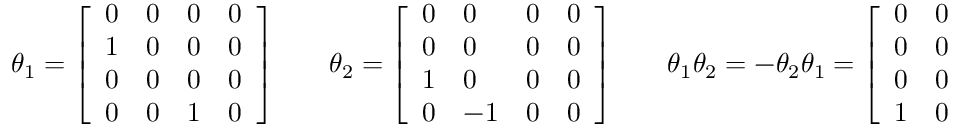<formula> <loc_0><loc_0><loc_500><loc_500>\theta _ { 1 } = { \left [ \begin{array} { l l l l } { 0 } & { 0 } & { 0 } & { 0 } \\ { 1 } & { 0 } & { 0 } & { 0 } \\ { 0 } & { 0 } & { 0 } & { 0 } \\ { 0 } & { 0 } & { 1 } & { 0 } \end{array} \right ] } \quad \theta _ { 2 } = { \left [ \begin{array} { l l l l } { 0 } & { 0 } & { 0 } & { 0 } \\ { 0 } & { 0 } & { 0 } & { 0 } \\ { 1 } & { 0 } & { 0 } & { 0 } \\ { 0 } & { - 1 } & { 0 } & { 0 } \end{array} \right ] } \quad \theta _ { 1 } \theta _ { 2 } = - \theta _ { 2 } \theta _ { 1 } = { \left [ \begin{array} { l l l l } { 0 } & { 0 } & { 0 } & { 0 } \\ { 0 } & { 0 } & { 0 } & { 0 } \\ { 0 } & { 0 } & { 0 } & { 0 } \\ { 1 } & { 0 } & { 0 } & { 0 } \end{array} \right ] } .</formula> 